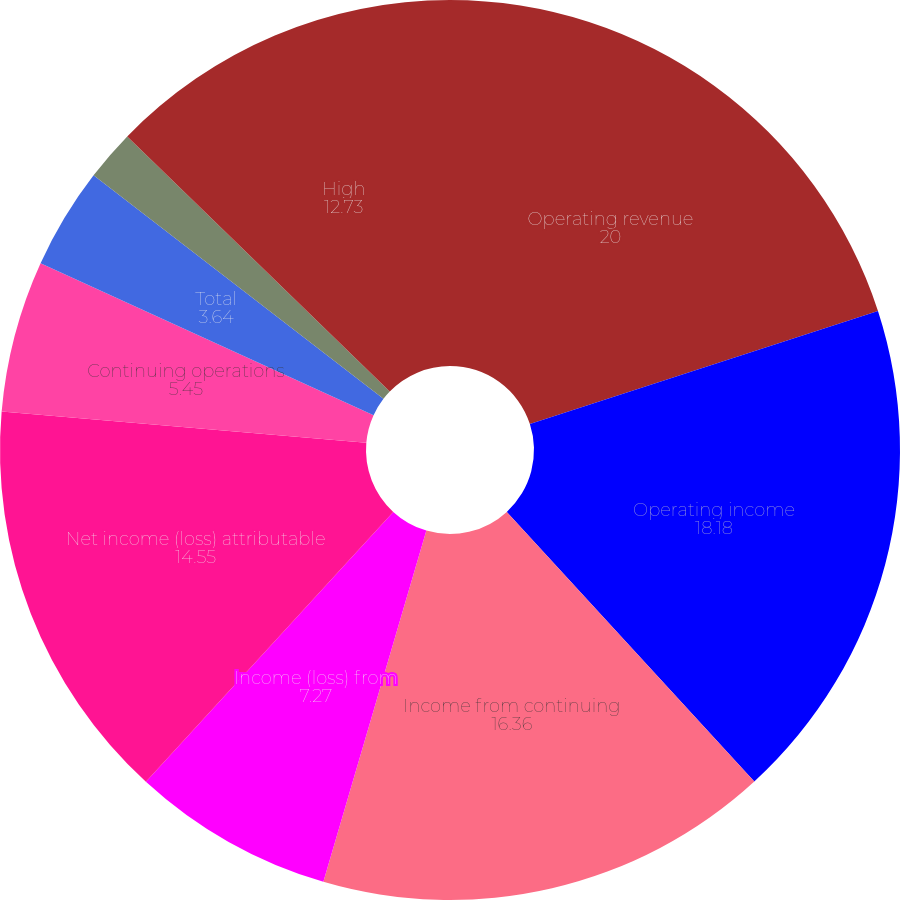<chart> <loc_0><loc_0><loc_500><loc_500><pie_chart><fcel>Operating revenue<fcel>Operating income<fcel>Income from continuing<fcel>Income (loss) from<fcel>Net income (loss) attributable<fcel>Continuing operations<fcel>Discontinued operations<fcel>Total<fcel>Dividends declared per share<fcel>High<nl><fcel>20.0%<fcel>18.18%<fcel>16.36%<fcel>7.27%<fcel>14.55%<fcel>5.45%<fcel>0.0%<fcel>3.64%<fcel>1.82%<fcel>12.73%<nl></chart> 